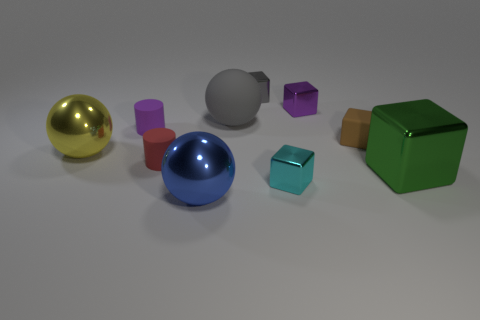Subtract all cyan shiny blocks. How many blocks are left? 4 Subtract 1 cubes. How many cubes are left? 4 Subtract all brown blocks. How many blocks are left? 4 Subtract all blue balls. Subtract all yellow cylinders. How many balls are left? 2 Subtract all balls. How many objects are left? 7 Subtract 1 cyan blocks. How many objects are left? 9 Subtract all big yellow balls. Subtract all small brown things. How many objects are left? 8 Add 3 tiny brown things. How many tiny brown things are left? 4 Add 9 tiny green rubber things. How many tiny green rubber things exist? 9 